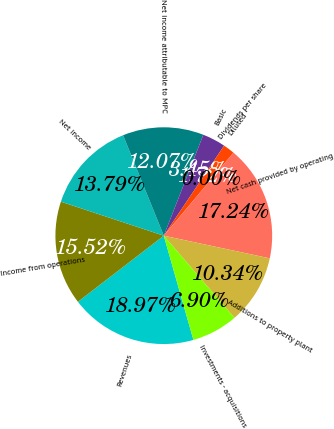Convert chart to OTSL. <chart><loc_0><loc_0><loc_500><loc_500><pie_chart><fcel>Revenues<fcel>Income from operations<fcel>Net income<fcel>Net income attributable to MPC<fcel>Basic<fcel>Diluted<fcel>Dividends per share<fcel>Net cash provided by operating<fcel>Additions to property plant<fcel>Investments - acquisitions<nl><fcel>18.97%<fcel>15.52%<fcel>13.79%<fcel>12.07%<fcel>3.45%<fcel>1.72%<fcel>0.0%<fcel>17.24%<fcel>10.34%<fcel>6.9%<nl></chart> 